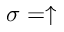<formula> <loc_0><loc_0><loc_500><loc_500>\sigma = \uparrow</formula> 